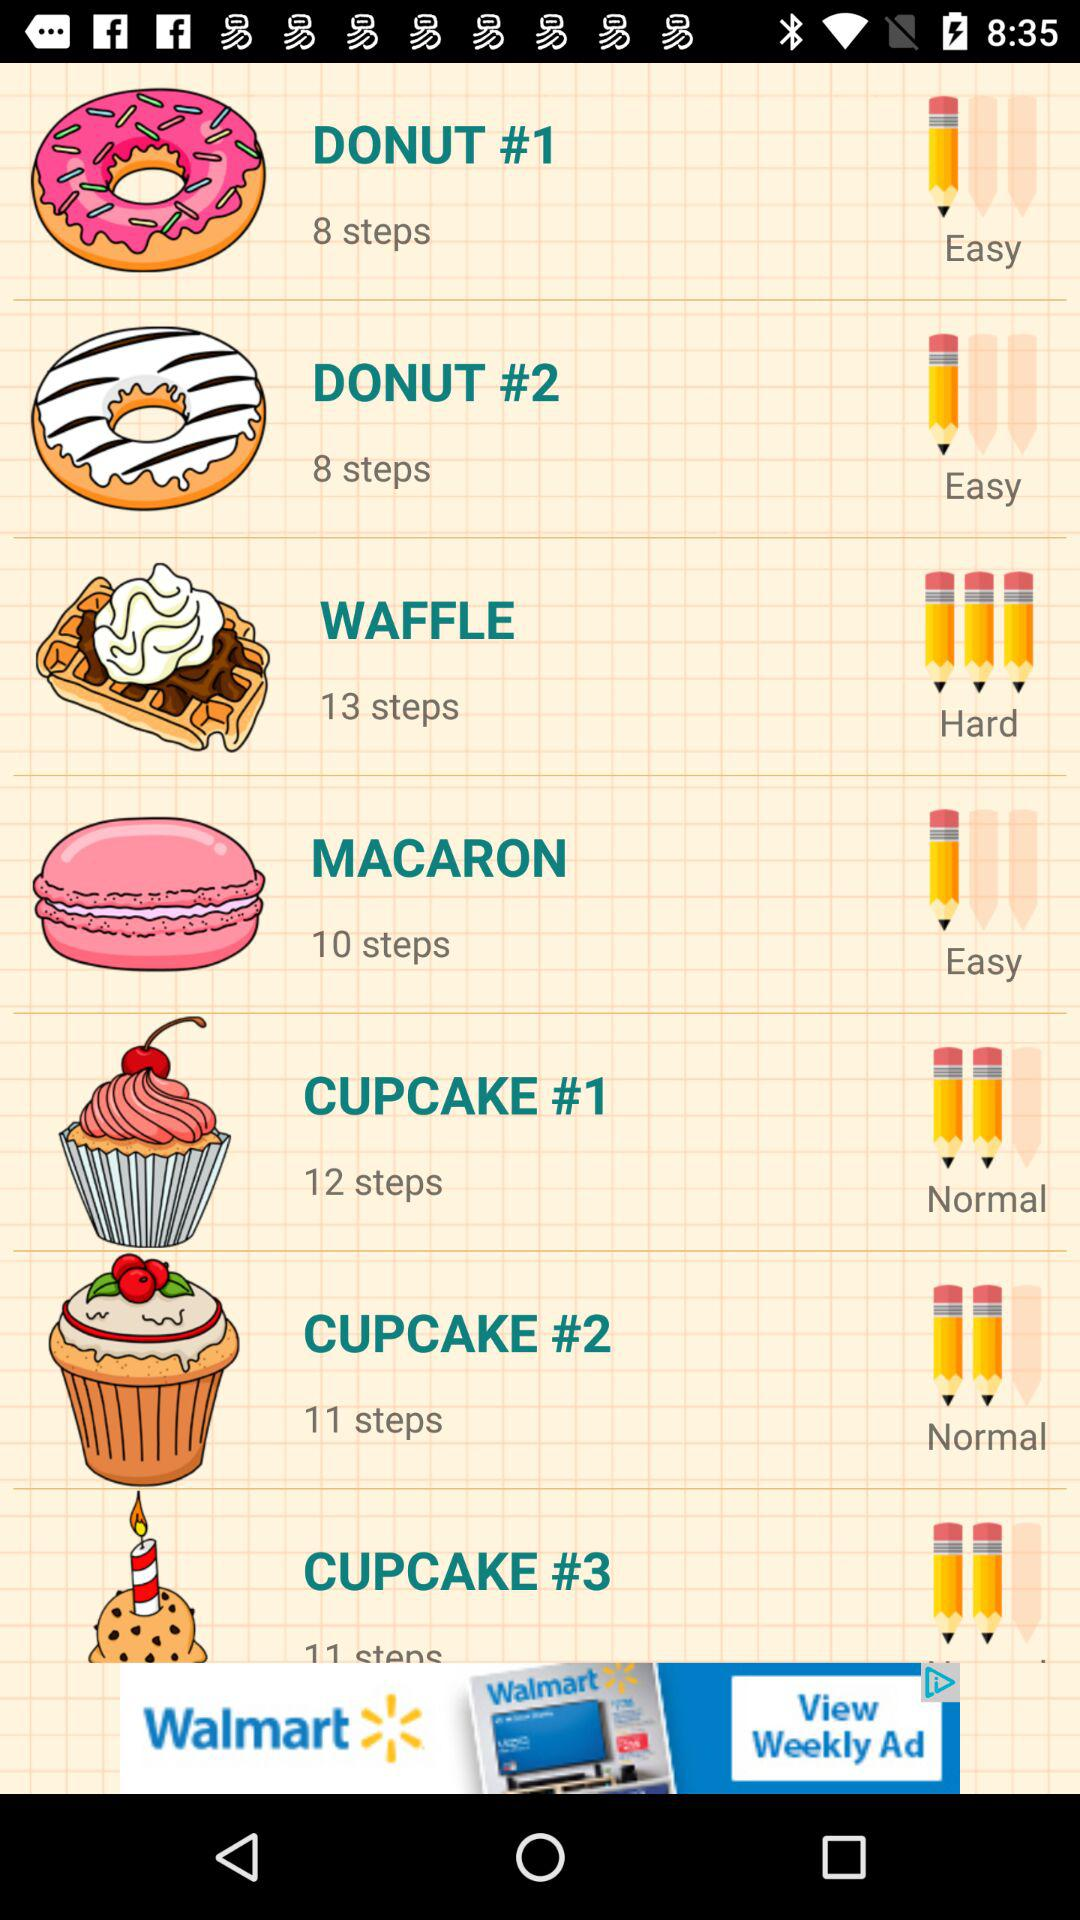Is it normal cupcake #1?
When the provided information is insufficient, respond with <no answer>. <no answer> 